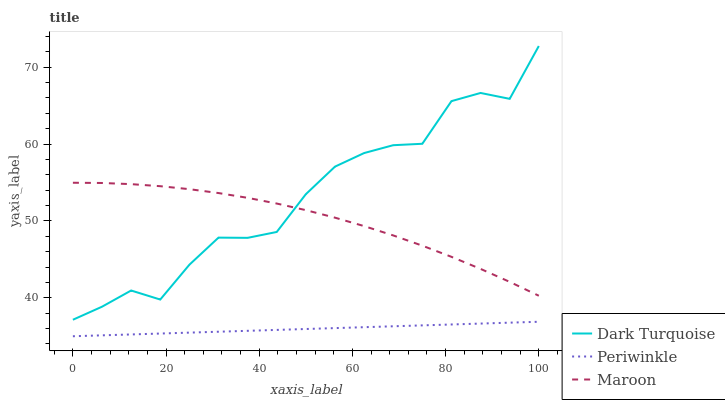Does Periwinkle have the minimum area under the curve?
Answer yes or no. Yes. Does Dark Turquoise have the maximum area under the curve?
Answer yes or no. Yes. Does Maroon have the minimum area under the curve?
Answer yes or no. No. Does Maroon have the maximum area under the curve?
Answer yes or no. No. Is Periwinkle the smoothest?
Answer yes or no. Yes. Is Dark Turquoise the roughest?
Answer yes or no. Yes. Is Maroon the smoothest?
Answer yes or no. No. Is Maroon the roughest?
Answer yes or no. No. Does Periwinkle have the lowest value?
Answer yes or no. Yes. Does Maroon have the lowest value?
Answer yes or no. No. Does Dark Turquoise have the highest value?
Answer yes or no. Yes. Does Maroon have the highest value?
Answer yes or no. No. Is Periwinkle less than Maroon?
Answer yes or no. Yes. Is Dark Turquoise greater than Periwinkle?
Answer yes or no. Yes. Does Dark Turquoise intersect Maroon?
Answer yes or no. Yes. Is Dark Turquoise less than Maroon?
Answer yes or no. No. Is Dark Turquoise greater than Maroon?
Answer yes or no. No. Does Periwinkle intersect Maroon?
Answer yes or no. No. 